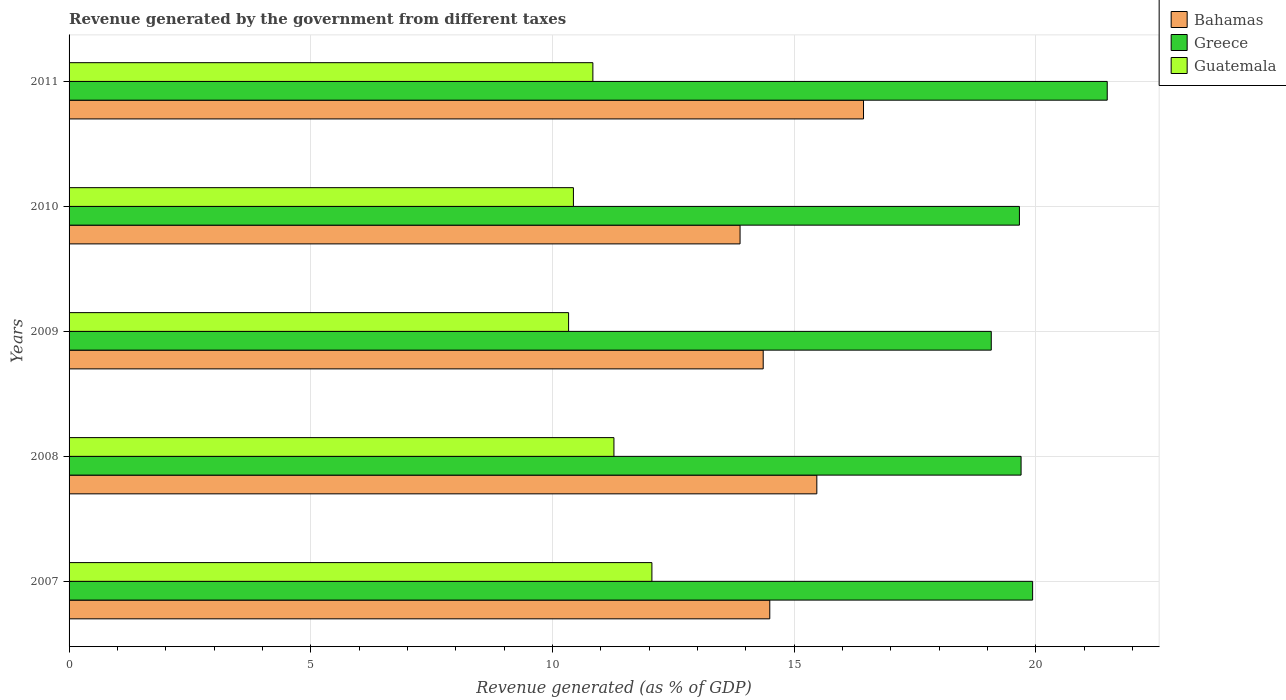Are the number of bars per tick equal to the number of legend labels?
Your answer should be very brief. Yes. Are the number of bars on each tick of the Y-axis equal?
Your answer should be compact. Yes. How many bars are there on the 2nd tick from the top?
Keep it short and to the point. 3. In how many cases, is the number of bars for a given year not equal to the number of legend labels?
Give a very brief answer. 0. What is the revenue generated by the government in Greece in 2011?
Offer a very short reply. 21.48. Across all years, what is the maximum revenue generated by the government in Guatemala?
Your answer should be compact. 12.06. Across all years, what is the minimum revenue generated by the government in Greece?
Your answer should be compact. 19.08. In which year was the revenue generated by the government in Guatemala minimum?
Provide a short and direct response. 2009. What is the total revenue generated by the government in Bahamas in the graph?
Your response must be concise. 74.65. What is the difference between the revenue generated by the government in Greece in 2007 and that in 2009?
Your answer should be very brief. 0.86. What is the difference between the revenue generated by the government in Guatemala in 2010 and the revenue generated by the government in Bahamas in 2009?
Your response must be concise. -3.93. What is the average revenue generated by the government in Guatemala per year?
Provide a short and direct response. 10.99. In the year 2008, what is the difference between the revenue generated by the government in Greece and revenue generated by the government in Bahamas?
Provide a succinct answer. 4.23. In how many years, is the revenue generated by the government in Bahamas greater than 13 %?
Offer a terse response. 5. What is the ratio of the revenue generated by the government in Bahamas in 2008 to that in 2009?
Give a very brief answer. 1.08. What is the difference between the highest and the second highest revenue generated by the government in Greece?
Offer a terse response. 1.54. What is the difference between the highest and the lowest revenue generated by the government in Greece?
Offer a terse response. 2.4. In how many years, is the revenue generated by the government in Greece greater than the average revenue generated by the government in Greece taken over all years?
Provide a short and direct response. 1. What does the 3rd bar from the top in 2008 represents?
Your response must be concise. Bahamas. What does the 1st bar from the bottom in 2008 represents?
Offer a very short reply. Bahamas. How many years are there in the graph?
Your answer should be very brief. 5. Does the graph contain any zero values?
Provide a succinct answer. No. Where does the legend appear in the graph?
Provide a succinct answer. Top right. How are the legend labels stacked?
Your response must be concise. Vertical. What is the title of the graph?
Your response must be concise. Revenue generated by the government from different taxes. Does "Palau" appear as one of the legend labels in the graph?
Provide a succinct answer. No. What is the label or title of the X-axis?
Your response must be concise. Revenue generated (as % of GDP). What is the label or title of the Y-axis?
Make the answer very short. Years. What is the Revenue generated (as % of GDP) in Bahamas in 2007?
Provide a succinct answer. 14.5. What is the Revenue generated (as % of GDP) of Greece in 2007?
Your response must be concise. 19.94. What is the Revenue generated (as % of GDP) of Guatemala in 2007?
Provide a short and direct response. 12.06. What is the Revenue generated (as % of GDP) in Bahamas in 2008?
Provide a short and direct response. 15.47. What is the Revenue generated (as % of GDP) of Greece in 2008?
Offer a terse response. 19.7. What is the Revenue generated (as % of GDP) of Guatemala in 2008?
Provide a succinct answer. 11.27. What is the Revenue generated (as % of GDP) of Bahamas in 2009?
Give a very brief answer. 14.36. What is the Revenue generated (as % of GDP) of Greece in 2009?
Your answer should be very brief. 19.08. What is the Revenue generated (as % of GDP) in Guatemala in 2009?
Your response must be concise. 10.34. What is the Revenue generated (as % of GDP) in Bahamas in 2010?
Give a very brief answer. 13.88. What is the Revenue generated (as % of GDP) of Greece in 2010?
Make the answer very short. 19.66. What is the Revenue generated (as % of GDP) in Guatemala in 2010?
Offer a terse response. 10.44. What is the Revenue generated (as % of GDP) of Bahamas in 2011?
Make the answer very short. 16.44. What is the Revenue generated (as % of GDP) in Greece in 2011?
Offer a terse response. 21.48. What is the Revenue generated (as % of GDP) of Guatemala in 2011?
Give a very brief answer. 10.84. Across all years, what is the maximum Revenue generated (as % of GDP) of Bahamas?
Make the answer very short. 16.44. Across all years, what is the maximum Revenue generated (as % of GDP) of Greece?
Provide a succinct answer. 21.48. Across all years, what is the maximum Revenue generated (as % of GDP) of Guatemala?
Give a very brief answer. 12.06. Across all years, what is the minimum Revenue generated (as % of GDP) of Bahamas?
Provide a succinct answer. 13.88. Across all years, what is the minimum Revenue generated (as % of GDP) of Greece?
Keep it short and to the point. 19.08. Across all years, what is the minimum Revenue generated (as % of GDP) of Guatemala?
Your answer should be compact. 10.34. What is the total Revenue generated (as % of GDP) in Bahamas in the graph?
Keep it short and to the point. 74.65. What is the total Revenue generated (as % of GDP) in Greece in the graph?
Offer a very short reply. 99.86. What is the total Revenue generated (as % of GDP) of Guatemala in the graph?
Your answer should be very brief. 54.94. What is the difference between the Revenue generated (as % of GDP) in Bahamas in 2007 and that in 2008?
Give a very brief answer. -0.97. What is the difference between the Revenue generated (as % of GDP) in Greece in 2007 and that in 2008?
Your answer should be very brief. 0.24. What is the difference between the Revenue generated (as % of GDP) of Guatemala in 2007 and that in 2008?
Make the answer very short. 0.79. What is the difference between the Revenue generated (as % of GDP) in Bahamas in 2007 and that in 2009?
Provide a succinct answer. 0.14. What is the difference between the Revenue generated (as % of GDP) of Greece in 2007 and that in 2009?
Keep it short and to the point. 0.86. What is the difference between the Revenue generated (as % of GDP) in Guatemala in 2007 and that in 2009?
Offer a terse response. 1.72. What is the difference between the Revenue generated (as % of GDP) of Bahamas in 2007 and that in 2010?
Offer a terse response. 0.62. What is the difference between the Revenue generated (as % of GDP) in Greece in 2007 and that in 2010?
Offer a very short reply. 0.27. What is the difference between the Revenue generated (as % of GDP) of Guatemala in 2007 and that in 2010?
Your response must be concise. 1.62. What is the difference between the Revenue generated (as % of GDP) in Bahamas in 2007 and that in 2011?
Your response must be concise. -1.94. What is the difference between the Revenue generated (as % of GDP) of Greece in 2007 and that in 2011?
Provide a short and direct response. -1.54. What is the difference between the Revenue generated (as % of GDP) in Guatemala in 2007 and that in 2011?
Provide a short and direct response. 1.22. What is the difference between the Revenue generated (as % of GDP) in Bahamas in 2008 and that in 2009?
Provide a succinct answer. 1.11. What is the difference between the Revenue generated (as % of GDP) of Greece in 2008 and that in 2009?
Provide a succinct answer. 0.62. What is the difference between the Revenue generated (as % of GDP) in Guatemala in 2008 and that in 2009?
Offer a terse response. 0.94. What is the difference between the Revenue generated (as % of GDP) of Bahamas in 2008 and that in 2010?
Your response must be concise. 1.59. What is the difference between the Revenue generated (as % of GDP) of Greece in 2008 and that in 2010?
Keep it short and to the point. 0.03. What is the difference between the Revenue generated (as % of GDP) in Guatemala in 2008 and that in 2010?
Offer a very short reply. 0.84. What is the difference between the Revenue generated (as % of GDP) of Bahamas in 2008 and that in 2011?
Offer a very short reply. -0.97. What is the difference between the Revenue generated (as % of GDP) of Greece in 2008 and that in 2011?
Your response must be concise. -1.78. What is the difference between the Revenue generated (as % of GDP) in Guatemala in 2008 and that in 2011?
Your answer should be very brief. 0.44. What is the difference between the Revenue generated (as % of GDP) in Bahamas in 2009 and that in 2010?
Ensure brevity in your answer.  0.48. What is the difference between the Revenue generated (as % of GDP) in Greece in 2009 and that in 2010?
Your response must be concise. -0.58. What is the difference between the Revenue generated (as % of GDP) in Guatemala in 2009 and that in 2010?
Keep it short and to the point. -0.1. What is the difference between the Revenue generated (as % of GDP) of Bahamas in 2009 and that in 2011?
Provide a succinct answer. -2.08. What is the difference between the Revenue generated (as % of GDP) of Greece in 2009 and that in 2011?
Your answer should be compact. -2.4. What is the difference between the Revenue generated (as % of GDP) in Guatemala in 2009 and that in 2011?
Your answer should be compact. -0.5. What is the difference between the Revenue generated (as % of GDP) of Bahamas in 2010 and that in 2011?
Provide a short and direct response. -2.55. What is the difference between the Revenue generated (as % of GDP) of Greece in 2010 and that in 2011?
Your answer should be compact. -1.82. What is the difference between the Revenue generated (as % of GDP) in Guatemala in 2010 and that in 2011?
Provide a short and direct response. -0.4. What is the difference between the Revenue generated (as % of GDP) of Bahamas in 2007 and the Revenue generated (as % of GDP) of Greece in 2008?
Provide a succinct answer. -5.2. What is the difference between the Revenue generated (as % of GDP) of Bahamas in 2007 and the Revenue generated (as % of GDP) of Guatemala in 2008?
Your answer should be compact. 3.22. What is the difference between the Revenue generated (as % of GDP) in Greece in 2007 and the Revenue generated (as % of GDP) in Guatemala in 2008?
Provide a succinct answer. 8.66. What is the difference between the Revenue generated (as % of GDP) of Bahamas in 2007 and the Revenue generated (as % of GDP) of Greece in 2009?
Your response must be concise. -4.58. What is the difference between the Revenue generated (as % of GDP) of Bahamas in 2007 and the Revenue generated (as % of GDP) of Guatemala in 2009?
Give a very brief answer. 4.16. What is the difference between the Revenue generated (as % of GDP) of Greece in 2007 and the Revenue generated (as % of GDP) of Guatemala in 2009?
Your answer should be very brief. 9.6. What is the difference between the Revenue generated (as % of GDP) in Bahamas in 2007 and the Revenue generated (as % of GDP) in Greece in 2010?
Offer a terse response. -5.17. What is the difference between the Revenue generated (as % of GDP) in Bahamas in 2007 and the Revenue generated (as % of GDP) in Guatemala in 2010?
Ensure brevity in your answer.  4.06. What is the difference between the Revenue generated (as % of GDP) of Greece in 2007 and the Revenue generated (as % of GDP) of Guatemala in 2010?
Provide a succinct answer. 9.5. What is the difference between the Revenue generated (as % of GDP) of Bahamas in 2007 and the Revenue generated (as % of GDP) of Greece in 2011?
Provide a short and direct response. -6.98. What is the difference between the Revenue generated (as % of GDP) of Bahamas in 2007 and the Revenue generated (as % of GDP) of Guatemala in 2011?
Provide a short and direct response. 3.66. What is the difference between the Revenue generated (as % of GDP) in Greece in 2007 and the Revenue generated (as % of GDP) in Guatemala in 2011?
Provide a succinct answer. 9.1. What is the difference between the Revenue generated (as % of GDP) of Bahamas in 2008 and the Revenue generated (as % of GDP) of Greece in 2009?
Offer a terse response. -3.61. What is the difference between the Revenue generated (as % of GDP) of Bahamas in 2008 and the Revenue generated (as % of GDP) of Guatemala in 2009?
Keep it short and to the point. 5.14. What is the difference between the Revenue generated (as % of GDP) in Greece in 2008 and the Revenue generated (as % of GDP) in Guatemala in 2009?
Offer a terse response. 9.36. What is the difference between the Revenue generated (as % of GDP) of Bahamas in 2008 and the Revenue generated (as % of GDP) of Greece in 2010?
Offer a very short reply. -4.19. What is the difference between the Revenue generated (as % of GDP) in Bahamas in 2008 and the Revenue generated (as % of GDP) in Guatemala in 2010?
Your answer should be compact. 5.04. What is the difference between the Revenue generated (as % of GDP) of Greece in 2008 and the Revenue generated (as % of GDP) of Guatemala in 2010?
Keep it short and to the point. 9.26. What is the difference between the Revenue generated (as % of GDP) of Bahamas in 2008 and the Revenue generated (as % of GDP) of Greece in 2011?
Offer a very short reply. -6.01. What is the difference between the Revenue generated (as % of GDP) of Bahamas in 2008 and the Revenue generated (as % of GDP) of Guatemala in 2011?
Your answer should be compact. 4.63. What is the difference between the Revenue generated (as % of GDP) of Greece in 2008 and the Revenue generated (as % of GDP) of Guatemala in 2011?
Keep it short and to the point. 8.86. What is the difference between the Revenue generated (as % of GDP) in Bahamas in 2009 and the Revenue generated (as % of GDP) in Greece in 2010?
Your response must be concise. -5.3. What is the difference between the Revenue generated (as % of GDP) in Bahamas in 2009 and the Revenue generated (as % of GDP) in Guatemala in 2010?
Your response must be concise. 3.93. What is the difference between the Revenue generated (as % of GDP) in Greece in 2009 and the Revenue generated (as % of GDP) in Guatemala in 2010?
Your answer should be very brief. 8.65. What is the difference between the Revenue generated (as % of GDP) of Bahamas in 2009 and the Revenue generated (as % of GDP) of Greece in 2011?
Your answer should be very brief. -7.12. What is the difference between the Revenue generated (as % of GDP) in Bahamas in 2009 and the Revenue generated (as % of GDP) in Guatemala in 2011?
Make the answer very short. 3.52. What is the difference between the Revenue generated (as % of GDP) in Greece in 2009 and the Revenue generated (as % of GDP) in Guatemala in 2011?
Make the answer very short. 8.24. What is the difference between the Revenue generated (as % of GDP) of Bahamas in 2010 and the Revenue generated (as % of GDP) of Greece in 2011?
Provide a succinct answer. -7.6. What is the difference between the Revenue generated (as % of GDP) of Bahamas in 2010 and the Revenue generated (as % of GDP) of Guatemala in 2011?
Offer a terse response. 3.05. What is the difference between the Revenue generated (as % of GDP) of Greece in 2010 and the Revenue generated (as % of GDP) of Guatemala in 2011?
Give a very brief answer. 8.83. What is the average Revenue generated (as % of GDP) in Bahamas per year?
Provide a succinct answer. 14.93. What is the average Revenue generated (as % of GDP) of Greece per year?
Your answer should be very brief. 19.97. What is the average Revenue generated (as % of GDP) of Guatemala per year?
Provide a succinct answer. 10.99. In the year 2007, what is the difference between the Revenue generated (as % of GDP) of Bahamas and Revenue generated (as % of GDP) of Greece?
Offer a very short reply. -5.44. In the year 2007, what is the difference between the Revenue generated (as % of GDP) of Bahamas and Revenue generated (as % of GDP) of Guatemala?
Keep it short and to the point. 2.44. In the year 2007, what is the difference between the Revenue generated (as % of GDP) of Greece and Revenue generated (as % of GDP) of Guatemala?
Offer a very short reply. 7.88. In the year 2008, what is the difference between the Revenue generated (as % of GDP) of Bahamas and Revenue generated (as % of GDP) of Greece?
Keep it short and to the point. -4.23. In the year 2008, what is the difference between the Revenue generated (as % of GDP) of Bahamas and Revenue generated (as % of GDP) of Guatemala?
Give a very brief answer. 4.2. In the year 2008, what is the difference between the Revenue generated (as % of GDP) in Greece and Revenue generated (as % of GDP) in Guatemala?
Keep it short and to the point. 8.42. In the year 2009, what is the difference between the Revenue generated (as % of GDP) of Bahamas and Revenue generated (as % of GDP) of Greece?
Provide a short and direct response. -4.72. In the year 2009, what is the difference between the Revenue generated (as % of GDP) in Bahamas and Revenue generated (as % of GDP) in Guatemala?
Your response must be concise. 4.03. In the year 2009, what is the difference between the Revenue generated (as % of GDP) in Greece and Revenue generated (as % of GDP) in Guatemala?
Ensure brevity in your answer.  8.75. In the year 2010, what is the difference between the Revenue generated (as % of GDP) of Bahamas and Revenue generated (as % of GDP) of Greece?
Your answer should be very brief. -5.78. In the year 2010, what is the difference between the Revenue generated (as % of GDP) in Bahamas and Revenue generated (as % of GDP) in Guatemala?
Offer a terse response. 3.45. In the year 2010, what is the difference between the Revenue generated (as % of GDP) of Greece and Revenue generated (as % of GDP) of Guatemala?
Provide a succinct answer. 9.23. In the year 2011, what is the difference between the Revenue generated (as % of GDP) in Bahamas and Revenue generated (as % of GDP) in Greece?
Your response must be concise. -5.04. In the year 2011, what is the difference between the Revenue generated (as % of GDP) of Greece and Revenue generated (as % of GDP) of Guatemala?
Make the answer very short. 10.64. What is the ratio of the Revenue generated (as % of GDP) of Bahamas in 2007 to that in 2008?
Give a very brief answer. 0.94. What is the ratio of the Revenue generated (as % of GDP) of Greece in 2007 to that in 2008?
Provide a succinct answer. 1.01. What is the ratio of the Revenue generated (as % of GDP) in Guatemala in 2007 to that in 2008?
Your answer should be compact. 1.07. What is the ratio of the Revenue generated (as % of GDP) of Bahamas in 2007 to that in 2009?
Offer a terse response. 1.01. What is the ratio of the Revenue generated (as % of GDP) in Greece in 2007 to that in 2009?
Provide a short and direct response. 1.04. What is the ratio of the Revenue generated (as % of GDP) of Guatemala in 2007 to that in 2009?
Your answer should be very brief. 1.17. What is the ratio of the Revenue generated (as % of GDP) in Bahamas in 2007 to that in 2010?
Make the answer very short. 1.04. What is the ratio of the Revenue generated (as % of GDP) in Greece in 2007 to that in 2010?
Your answer should be compact. 1.01. What is the ratio of the Revenue generated (as % of GDP) in Guatemala in 2007 to that in 2010?
Offer a very short reply. 1.16. What is the ratio of the Revenue generated (as % of GDP) in Bahamas in 2007 to that in 2011?
Keep it short and to the point. 0.88. What is the ratio of the Revenue generated (as % of GDP) in Greece in 2007 to that in 2011?
Provide a short and direct response. 0.93. What is the ratio of the Revenue generated (as % of GDP) of Guatemala in 2007 to that in 2011?
Your answer should be very brief. 1.11. What is the ratio of the Revenue generated (as % of GDP) of Bahamas in 2008 to that in 2009?
Keep it short and to the point. 1.08. What is the ratio of the Revenue generated (as % of GDP) of Greece in 2008 to that in 2009?
Provide a succinct answer. 1.03. What is the ratio of the Revenue generated (as % of GDP) in Guatemala in 2008 to that in 2009?
Your response must be concise. 1.09. What is the ratio of the Revenue generated (as % of GDP) in Bahamas in 2008 to that in 2010?
Your response must be concise. 1.11. What is the ratio of the Revenue generated (as % of GDP) of Greece in 2008 to that in 2010?
Provide a succinct answer. 1. What is the ratio of the Revenue generated (as % of GDP) in Guatemala in 2008 to that in 2010?
Ensure brevity in your answer.  1.08. What is the ratio of the Revenue generated (as % of GDP) of Greece in 2008 to that in 2011?
Provide a short and direct response. 0.92. What is the ratio of the Revenue generated (as % of GDP) of Guatemala in 2008 to that in 2011?
Provide a succinct answer. 1.04. What is the ratio of the Revenue generated (as % of GDP) of Bahamas in 2009 to that in 2010?
Ensure brevity in your answer.  1.03. What is the ratio of the Revenue generated (as % of GDP) of Greece in 2009 to that in 2010?
Your answer should be very brief. 0.97. What is the ratio of the Revenue generated (as % of GDP) of Guatemala in 2009 to that in 2010?
Your response must be concise. 0.99. What is the ratio of the Revenue generated (as % of GDP) of Bahamas in 2009 to that in 2011?
Offer a very short reply. 0.87. What is the ratio of the Revenue generated (as % of GDP) of Greece in 2009 to that in 2011?
Offer a terse response. 0.89. What is the ratio of the Revenue generated (as % of GDP) in Guatemala in 2009 to that in 2011?
Keep it short and to the point. 0.95. What is the ratio of the Revenue generated (as % of GDP) in Bahamas in 2010 to that in 2011?
Provide a succinct answer. 0.84. What is the ratio of the Revenue generated (as % of GDP) in Greece in 2010 to that in 2011?
Your answer should be very brief. 0.92. What is the ratio of the Revenue generated (as % of GDP) in Guatemala in 2010 to that in 2011?
Your answer should be compact. 0.96. What is the difference between the highest and the second highest Revenue generated (as % of GDP) in Bahamas?
Ensure brevity in your answer.  0.97. What is the difference between the highest and the second highest Revenue generated (as % of GDP) of Greece?
Offer a terse response. 1.54. What is the difference between the highest and the second highest Revenue generated (as % of GDP) of Guatemala?
Your response must be concise. 0.79. What is the difference between the highest and the lowest Revenue generated (as % of GDP) in Bahamas?
Ensure brevity in your answer.  2.55. What is the difference between the highest and the lowest Revenue generated (as % of GDP) of Greece?
Make the answer very short. 2.4. What is the difference between the highest and the lowest Revenue generated (as % of GDP) of Guatemala?
Your response must be concise. 1.72. 